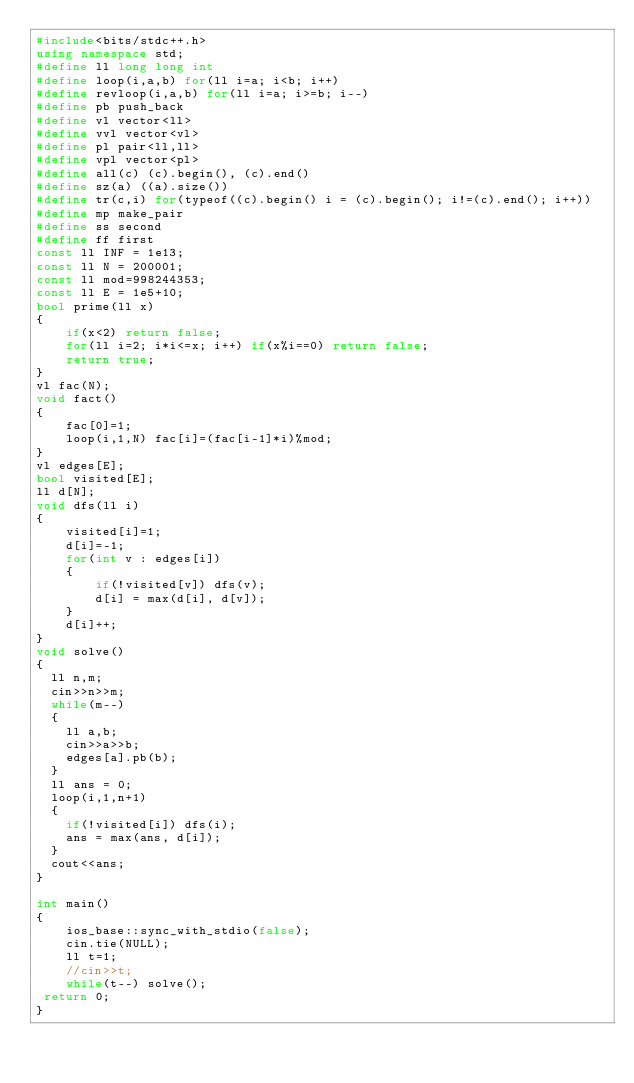<code> <loc_0><loc_0><loc_500><loc_500><_C++_>#include<bits/stdc++.h>
using namespace std;
#define ll long long int
#define loop(i,a,b) for(ll i=a; i<b; i++)
#define revloop(i,a,b) for(ll i=a; i>=b; i--)
#define pb push_back
#define vl vector<ll>
#define vvl vector<vl>
#define pl pair<ll,ll>
#define vpl vector<pl>
#define all(c) (c).begin(), (c).end()
#define sz(a) ((a).size())
#define tr(c,i) for(typeof((c).begin() i = (c).begin(); i!=(c).end(); i++))
#define mp make_pair
#define ss second
#define ff first
const ll INF = 1e13;
const ll N = 200001;
const ll mod=998244353;
const ll E = 1e5+10;
bool prime(ll x)
{
	if(x<2) return false;
	for(ll i=2; i*i<=x; i++) if(x%i==0) return false;
	return true;
}
vl fac(N);
void fact()
{
	fac[0]=1;
	loop(i,1,N) fac[i]=(fac[i-1]*i)%mod;
}
vl edges[E];
bool visited[E];
ll d[N];
void dfs(ll i)
{
	visited[i]=1;
	d[i]=-1;
	for(int v : edges[i])
	{
		if(!visited[v]) dfs(v);
		d[i] = max(d[i], d[v]);
	}
	d[i]++;
}
void solve()
{
  ll n,m;
  cin>>n>>m;
  while(m--)
  {
  	ll a,b;
  	cin>>a>>b;
  	edges[a].pb(b);
  }
  ll ans = 0;
  loop(i,1,n+1)
  {
  	if(!visited[i]) dfs(i);
  	ans = max(ans, d[i]);
  }
  cout<<ans;
}

int main()
{
	ios_base::sync_with_stdio(false);
    cin.tie(NULL);
    ll t=1;
    //cin>>t;
    while(t--) solve();
 return 0;
}</code> 